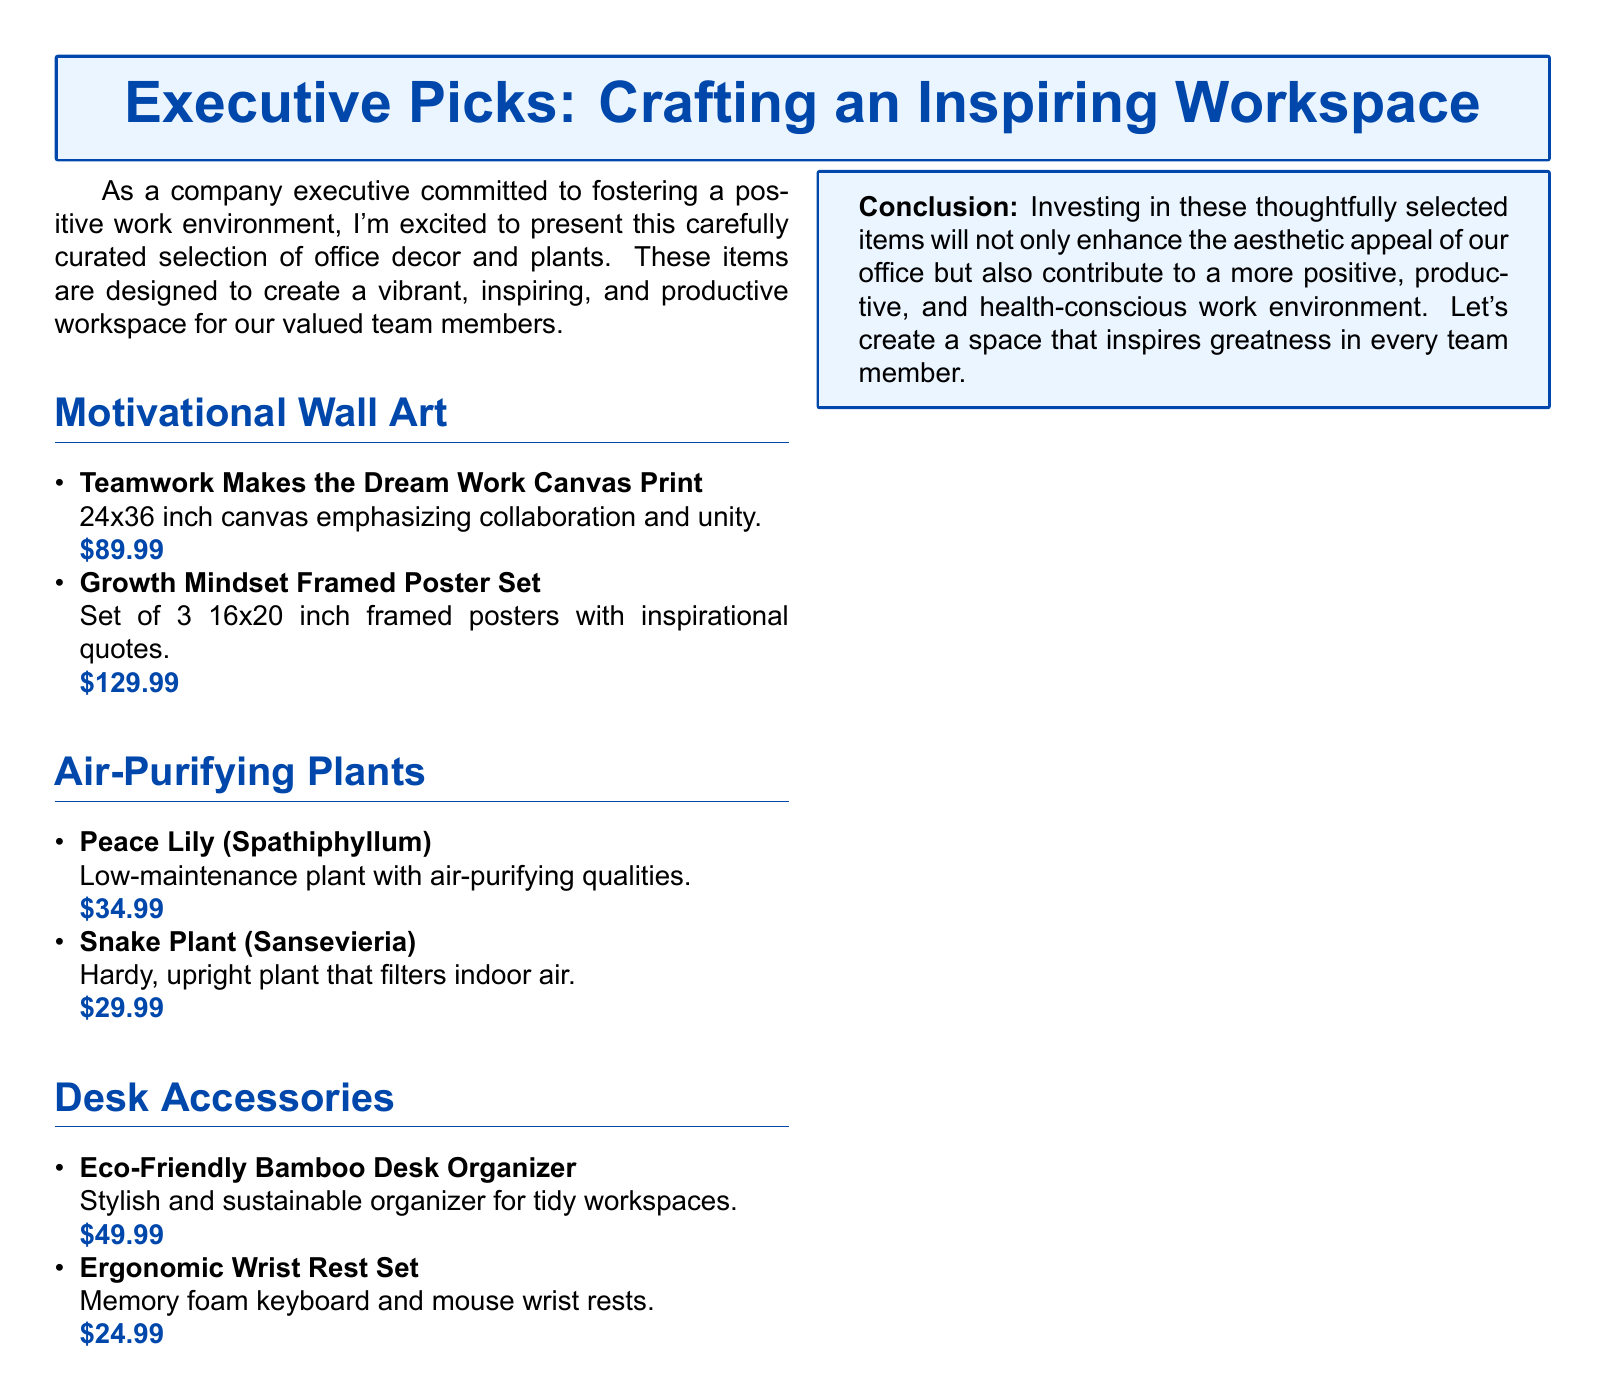What is the price of the Teamwork Makes the Dream Work Canvas Print? The price is stated in the item description under Motivational Wall Art.
Answer: $89.99 How many posters are included in the Growth Mindset Framed Poster Set? The number of posters is mentioned in the item description under Motivational Wall Art.
Answer: 3 What type of plant is the Peace Lily? The type of the plant is mentioned in the description under Air-Purifying Plants.
Answer: Spathiphyllum Which desk accessory is eco-friendly? The eco-friendliness of the item is specified in the description under Desk Accessories.
Answer: Eco-Friendly Bamboo Desk Organizer What are the dimensions of the Teamwork Makes the Dream Work Canvas Print? The dimensions are provided in the item's description under Motivational Wall Art.
Answer: 24x36 inch Which plant filters indoor air? The air-filtering quality is mentioned in the description under Air-Purifying Plants.
Answer: Snake Plant What material is the Ergonomic Wrist Rest Set made of? The material of the wrist rest set is mentioned in the item description under Desk Accessories.
Answer: Memory foam What is the theme of the motivational wall art items? The theme is suggested by the titles and descriptions provided under Motivational Wall Art.
Answer: Collaboration and inspiration 